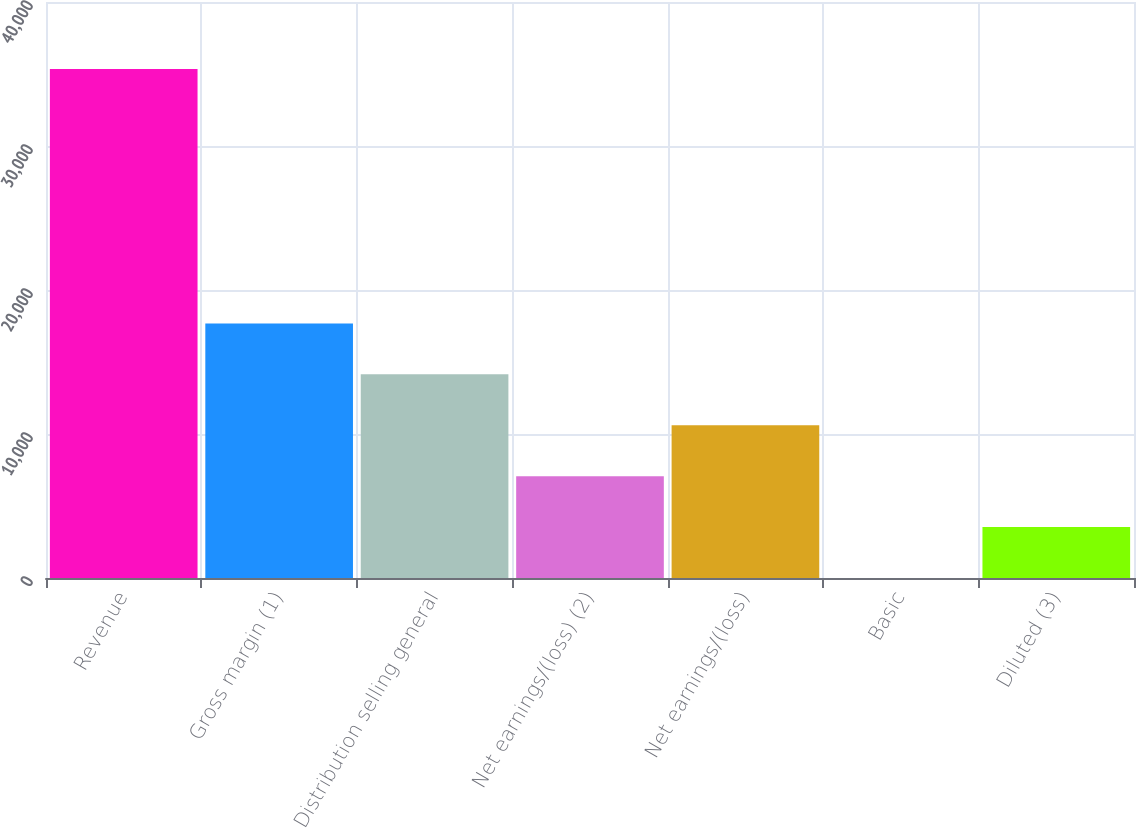<chart> <loc_0><loc_0><loc_500><loc_500><bar_chart><fcel>Revenue<fcel>Gross margin (1)<fcel>Distribution selling general<fcel>Net earnings/(loss) (2)<fcel>Net earnings/(loss)<fcel>Basic<fcel>Diluted (3)<nl><fcel>35349<fcel>17676.4<fcel>14141.8<fcel>7072.8<fcel>10607.3<fcel>3.76<fcel>3538.28<nl></chart> 